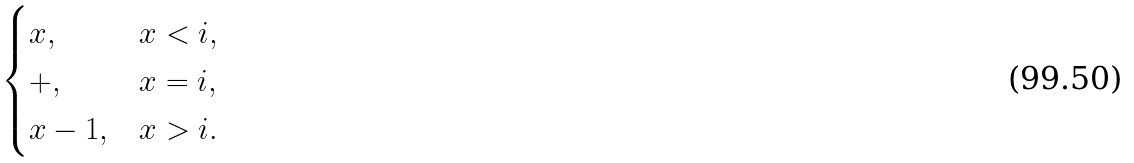Convert formula to latex. <formula><loc_0><loc_0><loc_500><loc_500>\begin{cases} x , & x < i , \\ + , & x = i , \\ x - 1 , & x > i . \end{cases}</formula> 